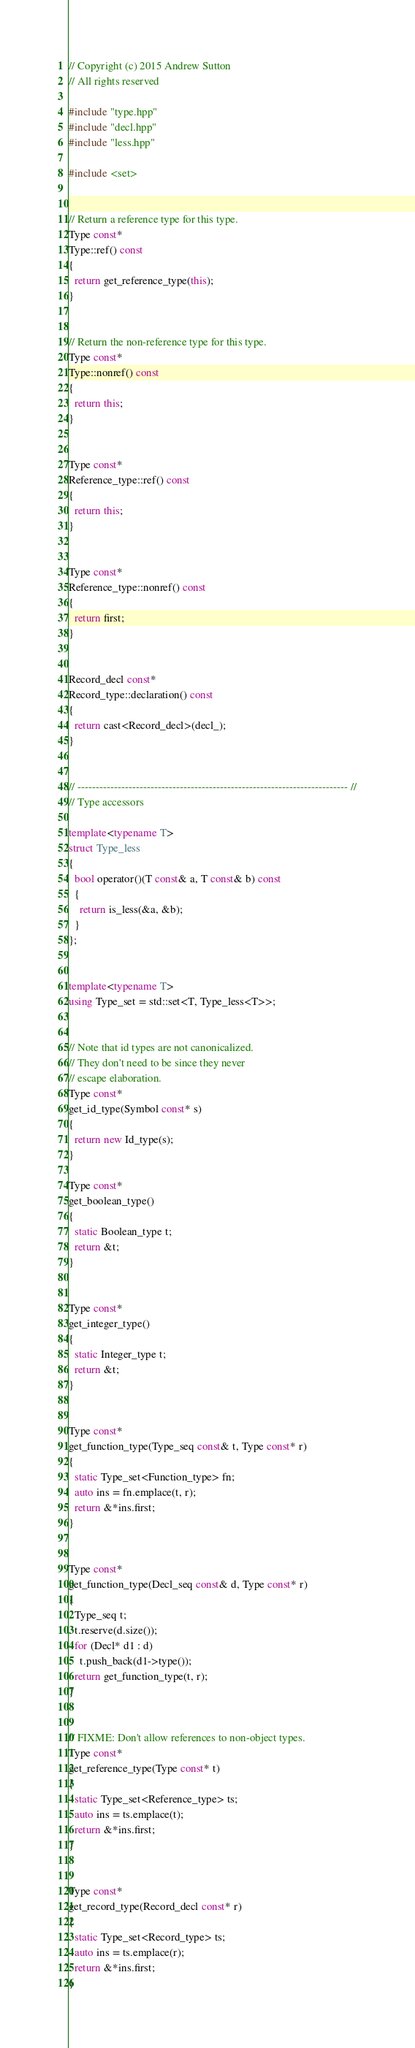<code> <loc_0><loc_0><loc_500><loc_500><_C++_>// Copyright (c) 2015 Andrew Sutton
// All rights reserved

#include "type.hpp"
#include "decl.hpp"
#include "less.hpp"

#include <set>


// Return a reference type for this type.
Type const*
Type::ref() const
{
  return get_reference_type(this);
}


// Return the non-reference type for this type.
Type const*
Type::nonref() const
{
  return this;
}


Type const*
Reference_type::ref() const
{
  return this;
}


Type const*
Reference_type::nonref() const
{
  return first;
}


Record_decl const*
Record_type::declaration() const
{
  return cast<Record_decl>(decl_);
}


// -------------------------------------------------------------------------- //
// Type accessors

template<typename T>
struct Type_less
{
  bool operator()(T const& a, T const& b) const
  {
    return is_less(&a, &b);
  }
};


template<typename T>
using Type_set = std::set<T, Type_less<T>>;


// Note that id types are not canonicalized.
// They don't need to be since they never
// escape elaboration.
Type const*
get_id_type(Symbol const* s)
{
  return new Id_type(s);
}

Type const*
get_boolean_type()
{
  static Boolean_type t;
  return &t;
}


Type const*
get_integer_type()
{
  static Integer_type t;
  return &t;
}


Type const*
get_function_type(Type_seq const& t, Type const* r)
{
  static Type_set<Function_type> fn;
  auto ins = fn.emplace(t, r);
  return &*ins.first;
}


Type const*
get_function_type(Decl_seq const& d, Type const* r)
{
  Type_seq t;
  t.reserve(d.size());
  for (Decl* d1 : d)
    t.push_back(d1->type());
  return get_function_type(t, r);
}


// FIXME: Don't allow references to non-object types.
Type const*
get_reference_type(Type const* t)
{
  static Type_set<Reference_type> ts;
  auto ins = ts.emplace(t);
  return &*ins.first;
}


Type const*
get_record_type(Record_decl const* r)
{
  static Type_set<Record_type> ts;
  auto ins = ts.emplace(r);
  return &*ins.first;
}
</code> 